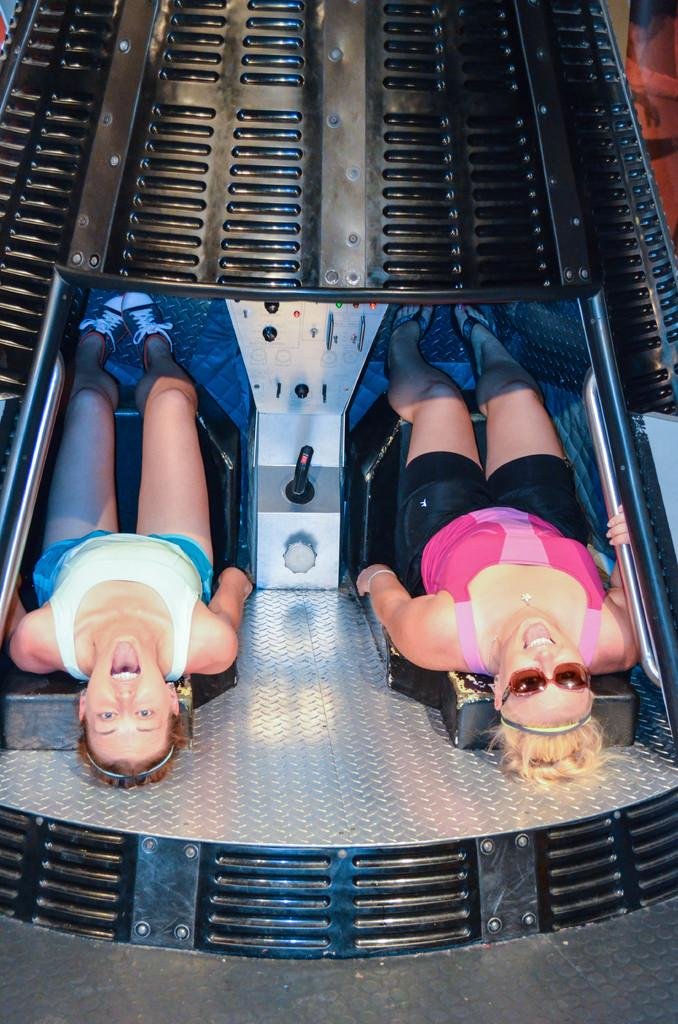What is the primary subject of the image? The primary subject of the image is women. What are the women doing in the image? The women are sitting on seats and smiling. Can you describe any specific features of one of the women? One woman is wearing spectacles. What type of duck can be seen on the stage in the image? There is no duck or stage present in the image; it features women sitting on seats and smiling. 